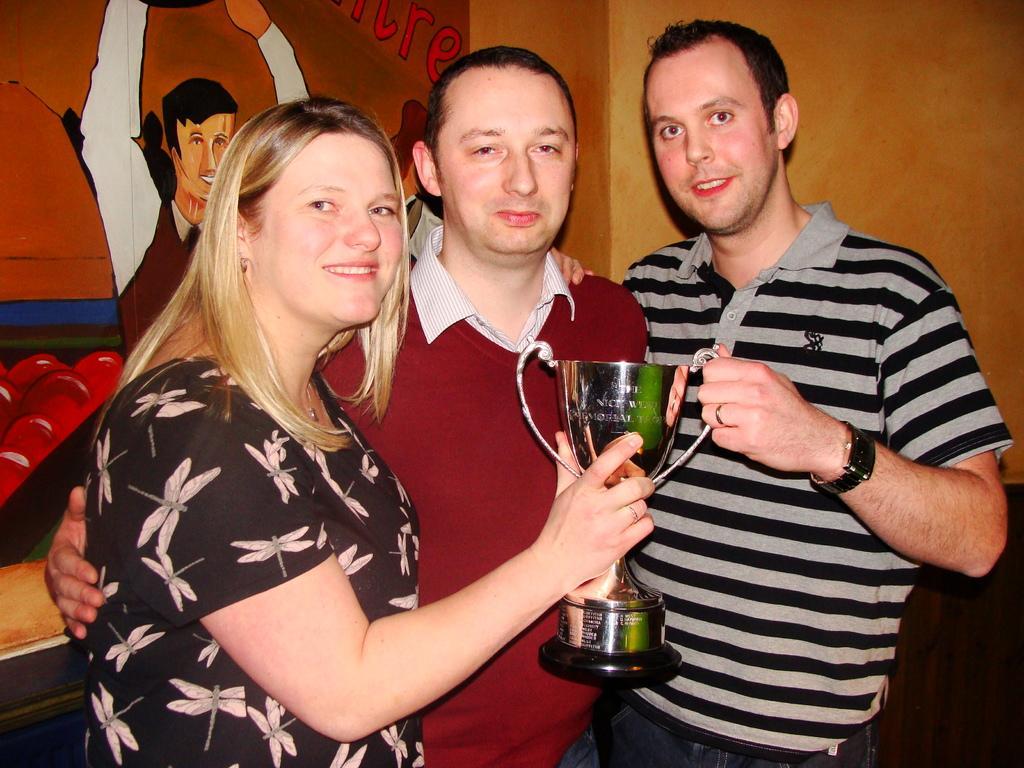Could you give a brief overview of what you see in this image? In the center of the image we can see three people standing and holding a trophy. In the background there is a board placed on the wall. 